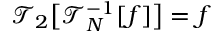Convert formula to latex. <formula><loc_0><loc_0><loc_500><loc_500>\mathcal { T } _ { 2 } \left [ \mathcal { T } _ { N } ^ { - 1 } [ f ] \right ] = f</formula> 